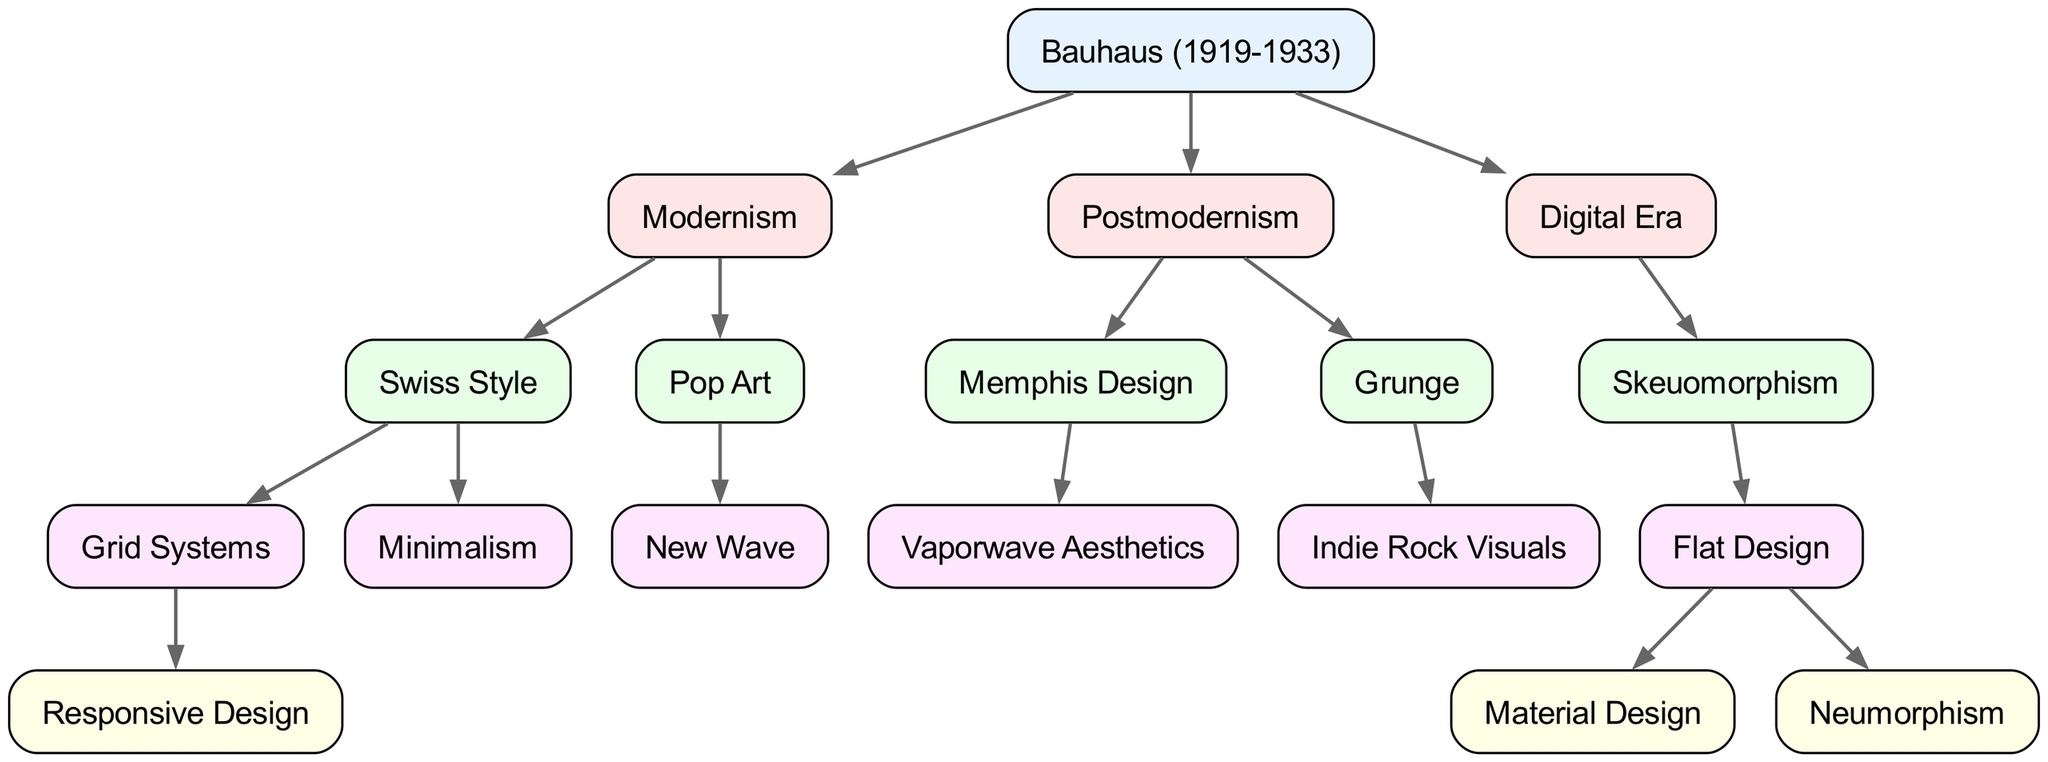What is the root node of the family tree? The root node is the starting point of the diagram, which is Bauhaus, as indicated at the top of the tree structure.
Answer: Bauhaus How many children does Modernism have? The children of Modernism can be counted by examining the branches coming directly from the Modernism node, which are Swiss Style and Pop Art. Thus, there are two children.
Answer: 2 Which design trend is a child of Postmodernism? To answer this, we look under Postmodernism in the diagram, where its children are listed. The design trend Memphis Design is one of those children.
Answer: Memphis Design What are the two styles under Flat Design? Flat Design has two direct descendant styles listed under it in the diagram: Material Design and Neumorphism. This requires identifying them directly from the diagram’s branches.
Answer: Material Design, Neumorphism Which style comes directly after Pop Art in the diagram? Following through the Pop Art node, we can see that its only child is New Wave, making it the direct descendant of Pop Art.
Answer: New Wave What is the relationship between Minimalism and Swiss Style? Minimalism is a child node that is directly descended from the Swiss Style node, indicating it is part of the Swiss Style design trend lineage.
Answer: Child Which design trend is linked to Vaporwave Aesthetics? Vaporwave Aesthetics is directly connected below the Memphis Design node in the diagram, indicating that it derives from Memphis Design.
Answer: Memphis Design How many total levels does the family tree have? The family tree can be examined from the root to the deepest point to determine the total levels. Starting from Bauhaus at the top to the most distant child, we can confirm that there are four levels in total.
Answer: 4 How many direct children does Digital Era have? Looking directly at the Digital Era node in the tree, it has only one child which is Skeuomorphism, making the count straightforward.
Answer: 1 Which trend appears under both Modernism and Postmodernism in the family tree? As we analyze both sections of the diagram, we note that there isn’t a trend that appears under both; thus, the answer is that there is no common trend between them.
Answer: None 